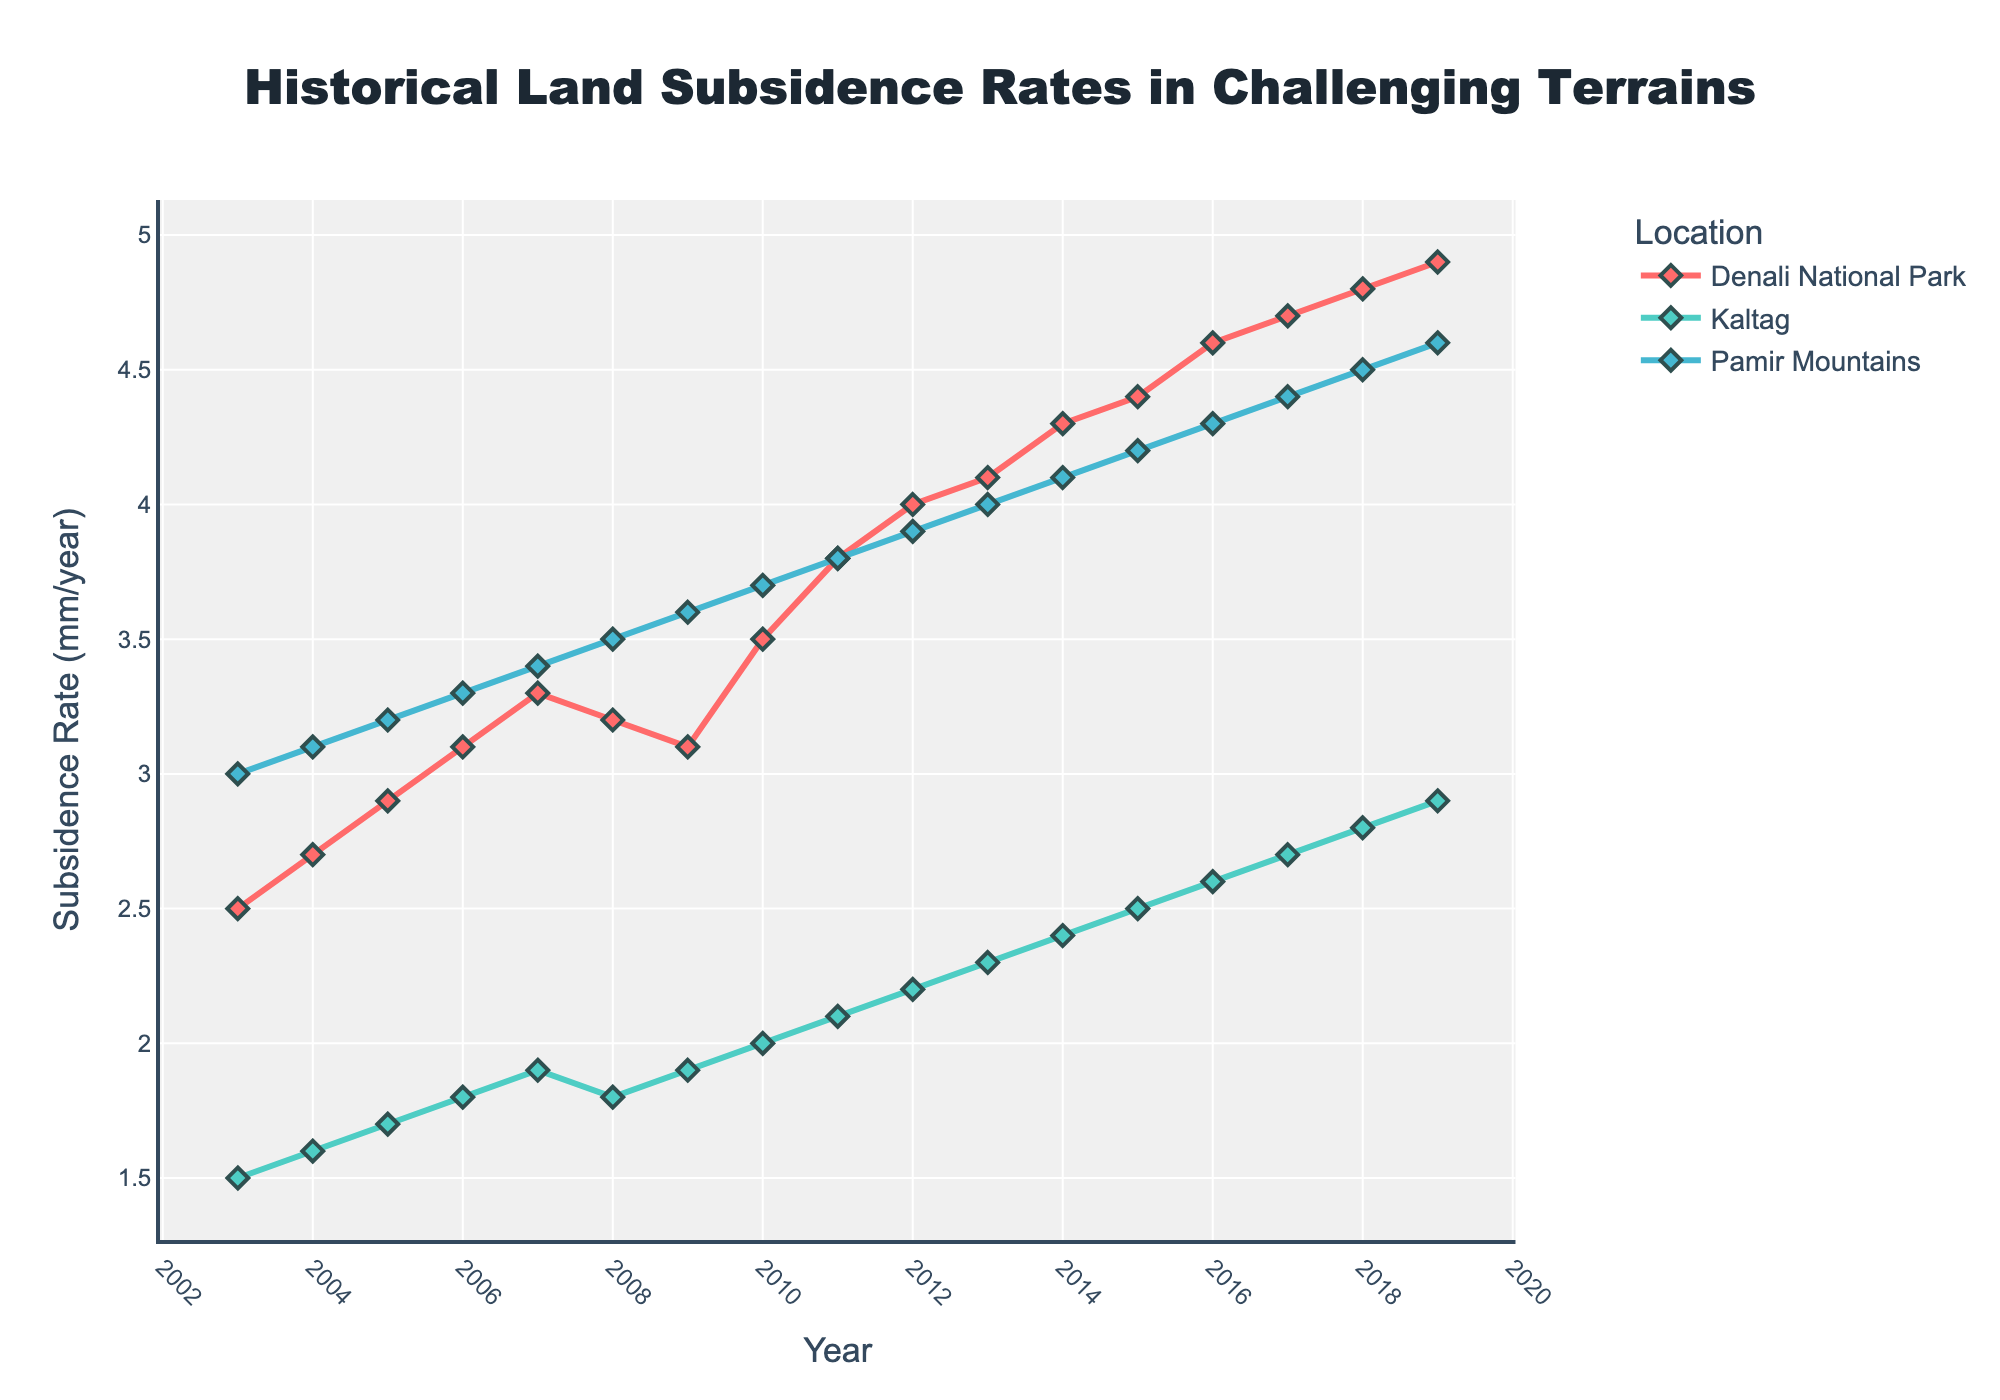What's the title of the figure? The title of the figure is usually prominently displayed at the top of the plot.
Answer: Historical Land Subsidence Rates in Challenging Terrains What is the subsidence rate in Kaltag in 2010? Look for the data point corresponding to Kaltag in 2010 on the plot.
Answer: 2.0 mm/year Which location exhibited the highest subsidence rate in 2019? Compare the data points for all three locations in the year 2019 to check for the highest rate.
Answer: Denali National Park How has the subsidence rate in Denali National Park changed from 2003 to 2008? Identify the data points for Denali National Park from 2003 to 2008 and track the changes in the subsidence rate.
Answer: It increased from 2.5 mm/year to 3.2 mm/year What is the average subsidence rate in Pamir Mountains from 2003 to 2006? Sum the subsidence rates for Pamir Mountains from 2003 to 2006 and divide by the number of years. (3.0 + 3.1 + 3.2 + 3.3) / 4 = 3.15
Answer: 3.15 mm/year Which location shows the least variability in subsidence rates over the entire period? Compare the overall trends and rate of change for each location across all years to determine which one has the least variability.
Answer: Kaltag What is the difference in subsidence rates between Pamir Mountains and Kaltag in 2012? Find the data points for both locations in 2012 and calculate the difference. Pamir Mountains: 3.9 mm/year, Kaltag: 2.2 mm/year. Difference: 3.9 - 2.2 = 1.7
Answer: 1.7 mm/year During which year did Denali National Park experience the highest annual increase in subsidence rate? Calculate the annual increases and determine the year with the largest change. From 2010 to 2011, the increase is 3.8 - 3.5 = 0.3 mm/year (highest annual increase).
Answer: 2011 Compare the trends in subsidence rates for the three locations from 2015 to 2019. What pattern do you observe? Analyze the data points and trends for each location from 2015 to 2019 and state the observed pattern.
Answer: All locations show a steady increase in subsidence rates 